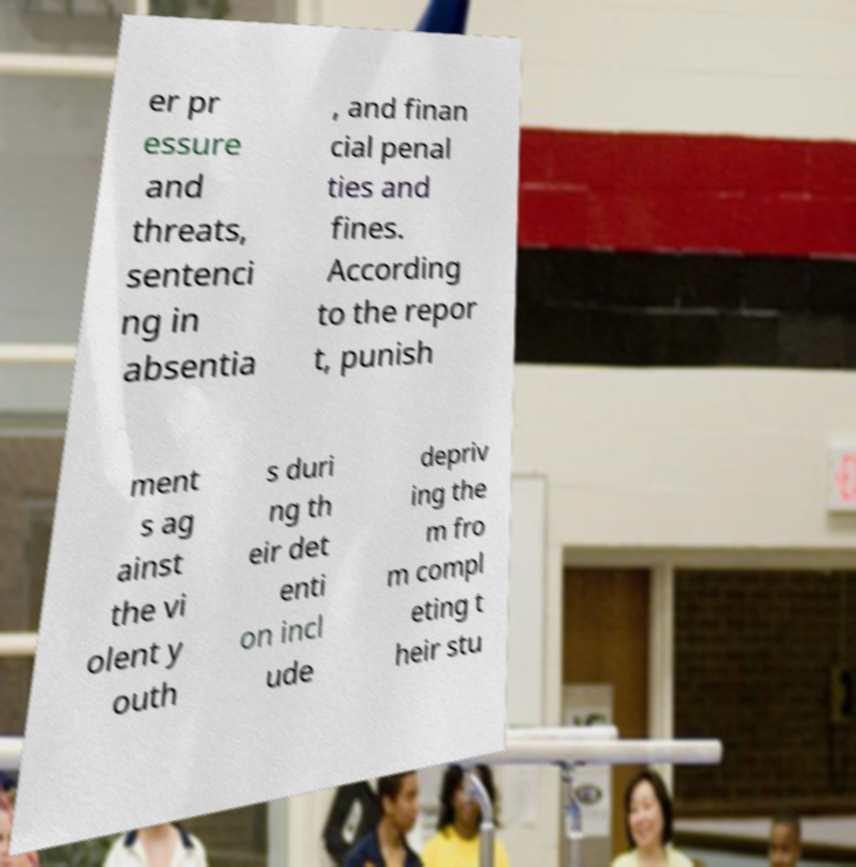For documentation purposes, I need the text within this image transcribed. Could you provide that? er pr essure and threats, sentenci ng in absentia , and finan cial penal ties and fines. According to the repor t, punish ment s ag ainst the vi olent y outh s duri ng th eir det enti on incl ude depriv ing the m fro m compl eting t heir stu 